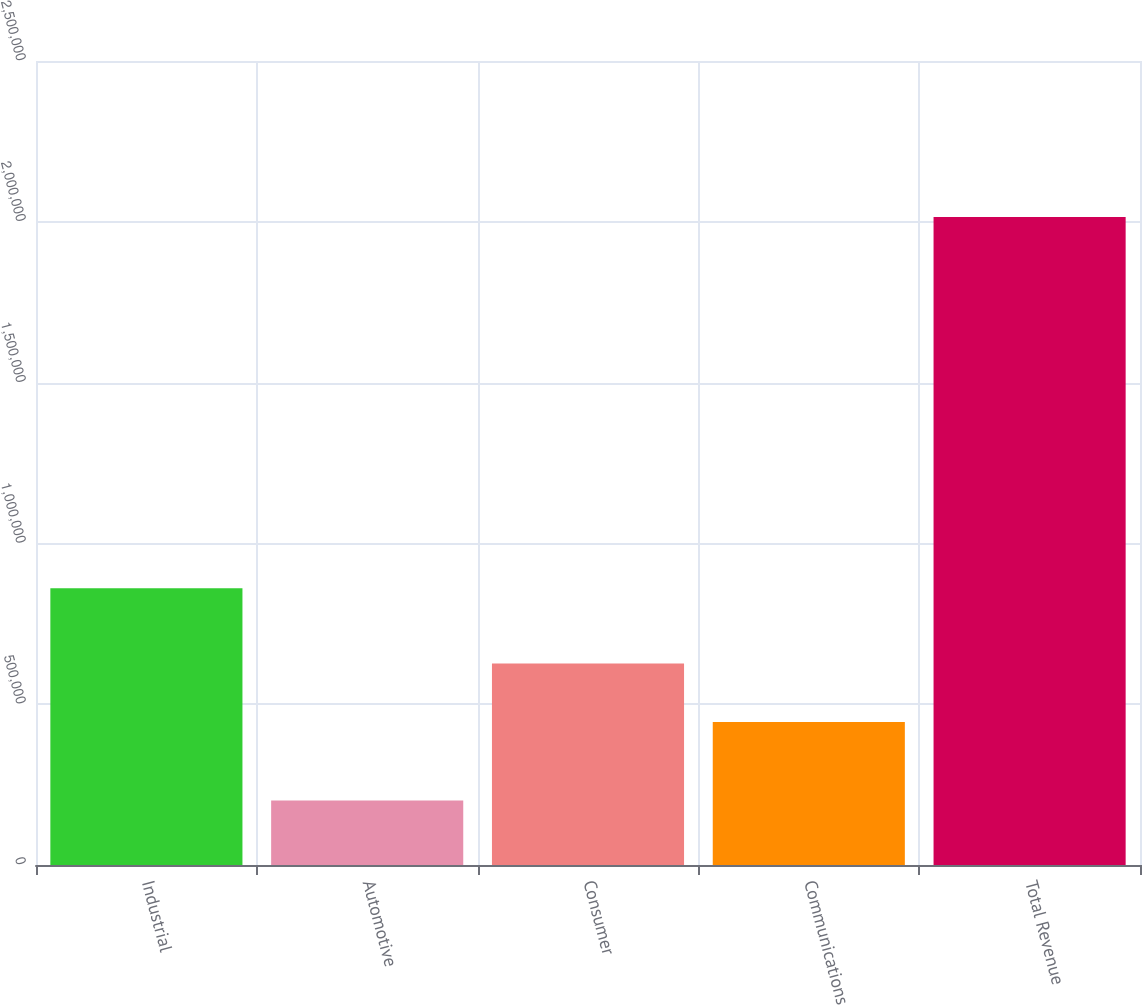Convert chart. <chart><loc_0><loc_0><loc_500><loc_500><bar_chart><fcel>Industrial<fcel>Automotive<fcel>Consumer<fcel>Communications<fcel>Total Revenue<nl><fcel>860696<fcel>200329<fcel>626493<fcel>445035<fcel>2.01491e+06<nl></chart> 